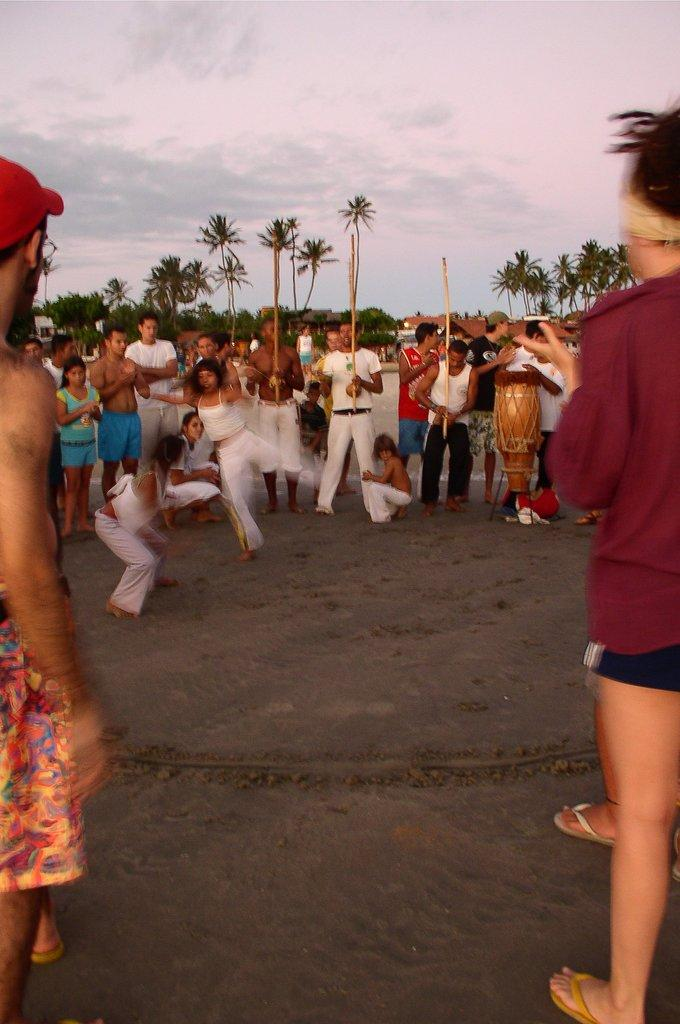How many people are in the image? There is a group of people standing in the image. What are the people in the image doing? There is a person playing a musical instrument in the image. What can be seen in the background of the image? There are trees in the background of the image. How would you describe the weather in the image? The sky is cloudy in the image, suggesting a potentially overcast or rainy day. What type of legal advice is the person playing the musical instrument seeking in the image? There is no indication in the image that the person playing the musical instrument is seeking legal advice, as the focus is on their musical performance. 